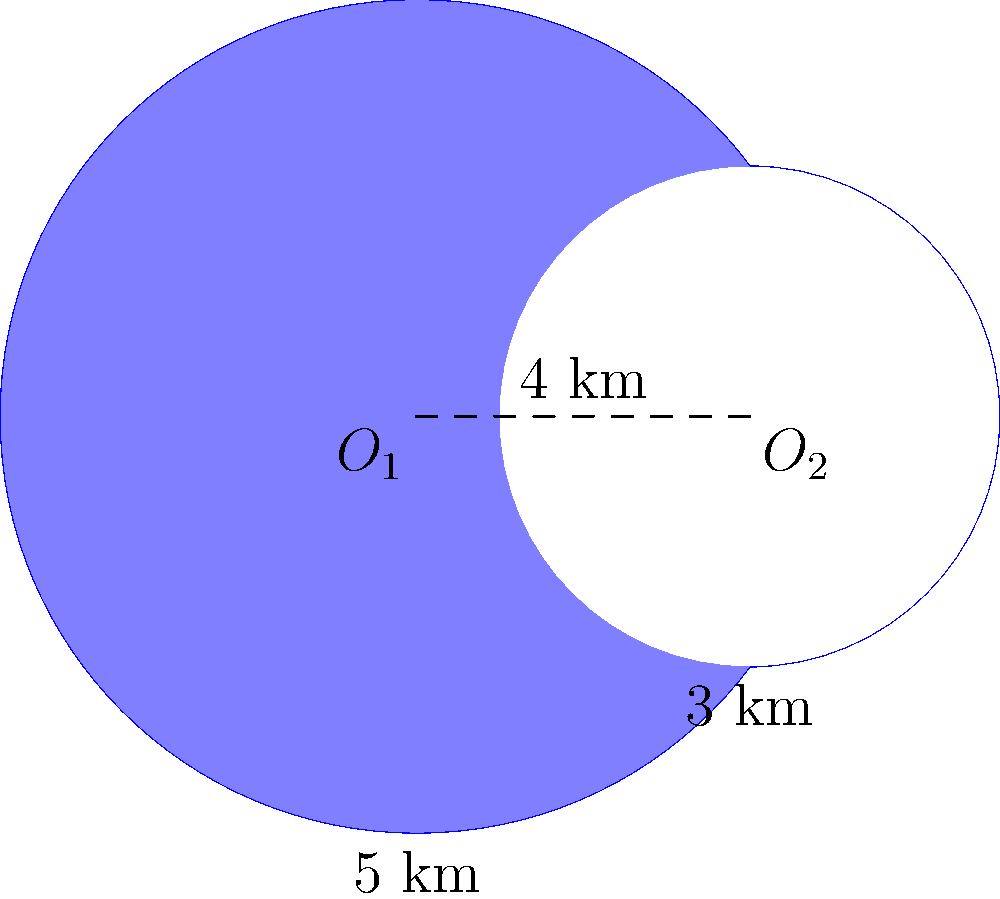During your desert safari expedition, you discover a crescent-shaped lake formed by two overlapping circular oases. The larger oasis has a radius of 5 km, while the smaller one has a radius of 3 km. The centers of the two circles are 4 km apart. Calculate the area of the crescent-shaped lake in square kilometers. To find the area of the crescent-shaped lake, we need to:

1. Calculate the area of the larger circle (A1)
2. Calculate the area of the smaller circle (A2)
3. Find the area of the lens-shaped overlap (A3)
4. Calculate the crescent area as A1 - A3

Step 1: Area of larger circle
$$A1 = \pi r_1^2 = \pi (5^2) = 25\pi \text{ km}^2$$

Step 2: Area of smaller circle
$$A2 = \pi r_2^2 = \pi (3^2) = 9\pi \text{ km}^2$$

Step 3: Area of lens-shaped overlap
To find this, we use the formula for the area of intersection of two circles:

$$A3 = r_1^2 \arccos(\frac{d^2 + r_1^2 - r_2^2}{2dr_1}) + r_2^2 \arccos(\frac{d^2 + r_2^2 - r_1^2}{2dr_2}) - \frac{1}{2}\sqrt{(-d+r_1+r_2)(d+r_1-r_2)(d-r_1+r_2)(d+r_1+r_2)}$$

Where $d$ is the distance between circle centers (4 km), $r_1 = 5$ km, and $r_2 = 3$ km.

Plugging in these values:

$$A3 = 25 \arccos(\frac{16 + 25 - 9}{40}) + 9 \arccos(\frac{16 + 9 - 25}{24}) - \frac{1}{2}\sqrt{(-4+5+3)(4+5-3)(4-5+3)(4+5+3)}$$

$$A3 \approx 25(0.6435) + 9(1.8238) - \frac{1}{2}\sqrt{4 \cdot 6 \cdot 2 \cdot 12}$$

$$A3 \approx 16.0875 + 16.4142 - 6$$

$$A3 \approx 26.5017 \text{ km}^2$$

Step 4: Crescent area
$$\text{Crescent Area} = A1 - A3 = 25\pi - 26.5017 \approx 52.0796 \text{ km}^2$$
Answer: 52.08 km² 